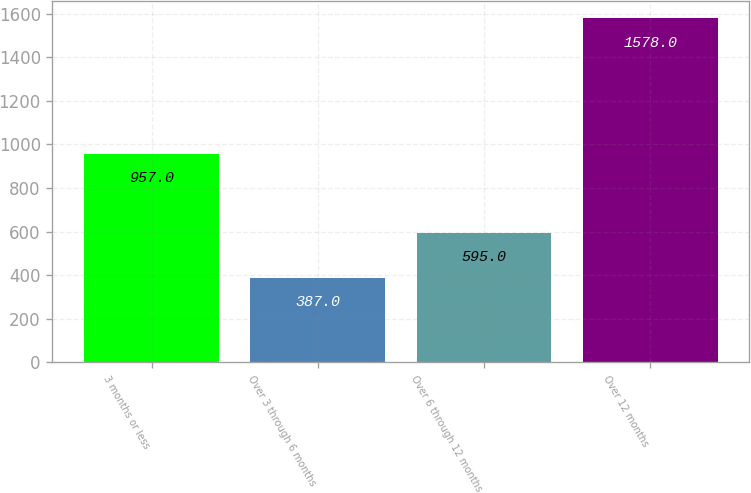<chart> <loc_0><loc_0><loc_500><loc_500><bar_chart><fcel>3 months or less<fcel>Over 3 through 6 months<fcel>Over 6 through 12 months<fcel>Over 12 months<nl><fcel>957<fcel>387<fcel>595<fcel>1578<nl></chart> 